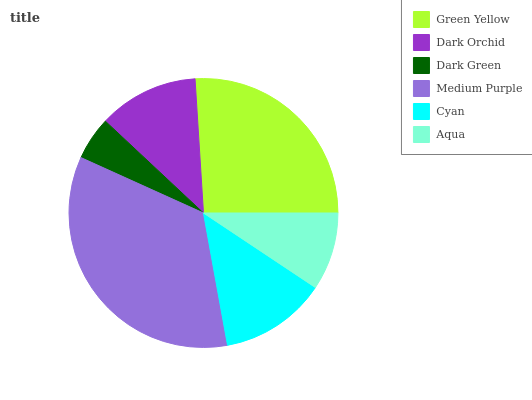Is Dark Green the minimum?
Answer yes or no. Yes. Is Medium Purple the maximum?
Answer yes or no. Yes. Is Dark Orchid the minimum?
Answer yes or no. No. Is Dark Orchid the maximum?
Answer yes or no. No. Is Green Yellow greater than Dark Orchid?
Answer yes or no. Yes. Is Dark Orchid less than Green Yellow?
Answer yes or no. Yes. Is Dark Orchid greater than Green Yellow?
Answer yes or no. No. Is Green Yellow less than Dark Orchid?
Answer yes or no. No. Is Cyan the high median?
Answer yes or no. Yes. Is Dark Orchid the low median?
Answer yes or no. Yes. Is Green Yellow the high median?
Answer yes or no. No. Is Dark Green the low median?
Answer yes or no. No. 